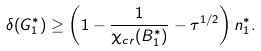<formula> <loc_0><loc_0><loc_500><loc_500>\delta ( G ^ { * } _ { 1 } ) \geq \left ( 1 - \frac { 1 } { \chi _ { c r } ( B _ { 1 } ^ { * } ) } - \tau ^ { 1 / 2 } \right ) n ^ { * } _ { 1 } .</formula> 